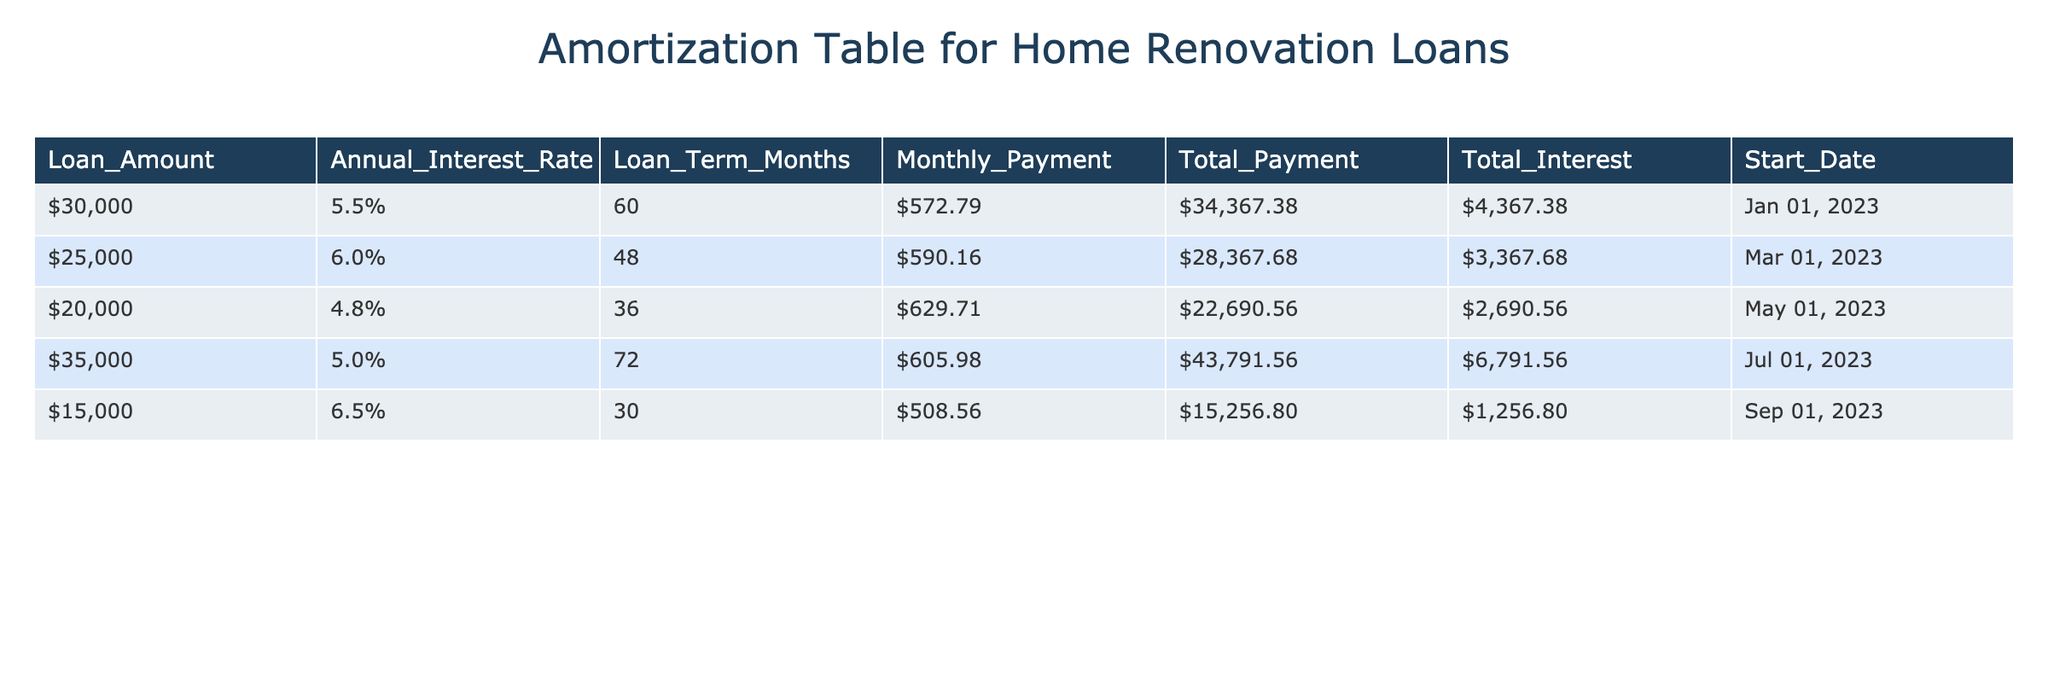What is the total payment for the $30,000 loan? The table shows the total payment for the $30,000 loan is $34,367.38. This information can be directly retrieved from the corresponding row in the table.
Answer: $34,367.38 What is the difference between the total interest of the $25,000 loan and the $15,000 loan? The total interest for the $25,000 loan is $3,367.68 and for the $15,000 loan it is $1,256.80. To find the difference, subtract the total interest of the $15,000 loan from that of the $25,000 loan: $3,367.68 - $1,256.80 = $2,110.88.
Answer: $2,110.88 Is the annual interest rate for the $20,000 loan lower than 5%? The annual interest rate for the $20,000 loan is 4.8%, which is indeed lower than 5%. This is checked by comparing the value in the table directly.
Answer: Yes What is the average monthly payment across all loans listed in the table? The monthly payments are $572.79, $590.16, $629.71, $605.98, and $508.56. To find the average, sum these values: $572.79 + $590.16 + $629.71 + $605.98 + $508.56 = $2,907.20. Then divide by the number of loans (5): $2,907.20 / 5 = $581.44.
Answer: $581.44 Which loan has the highest total interest, and what is the amount? The loan with the highest total interest is the $35,000 loan, with a total interest of $6,791.56. This is determined by comparing the total interest values across all loans in the table.
Answer: $6,791.56 